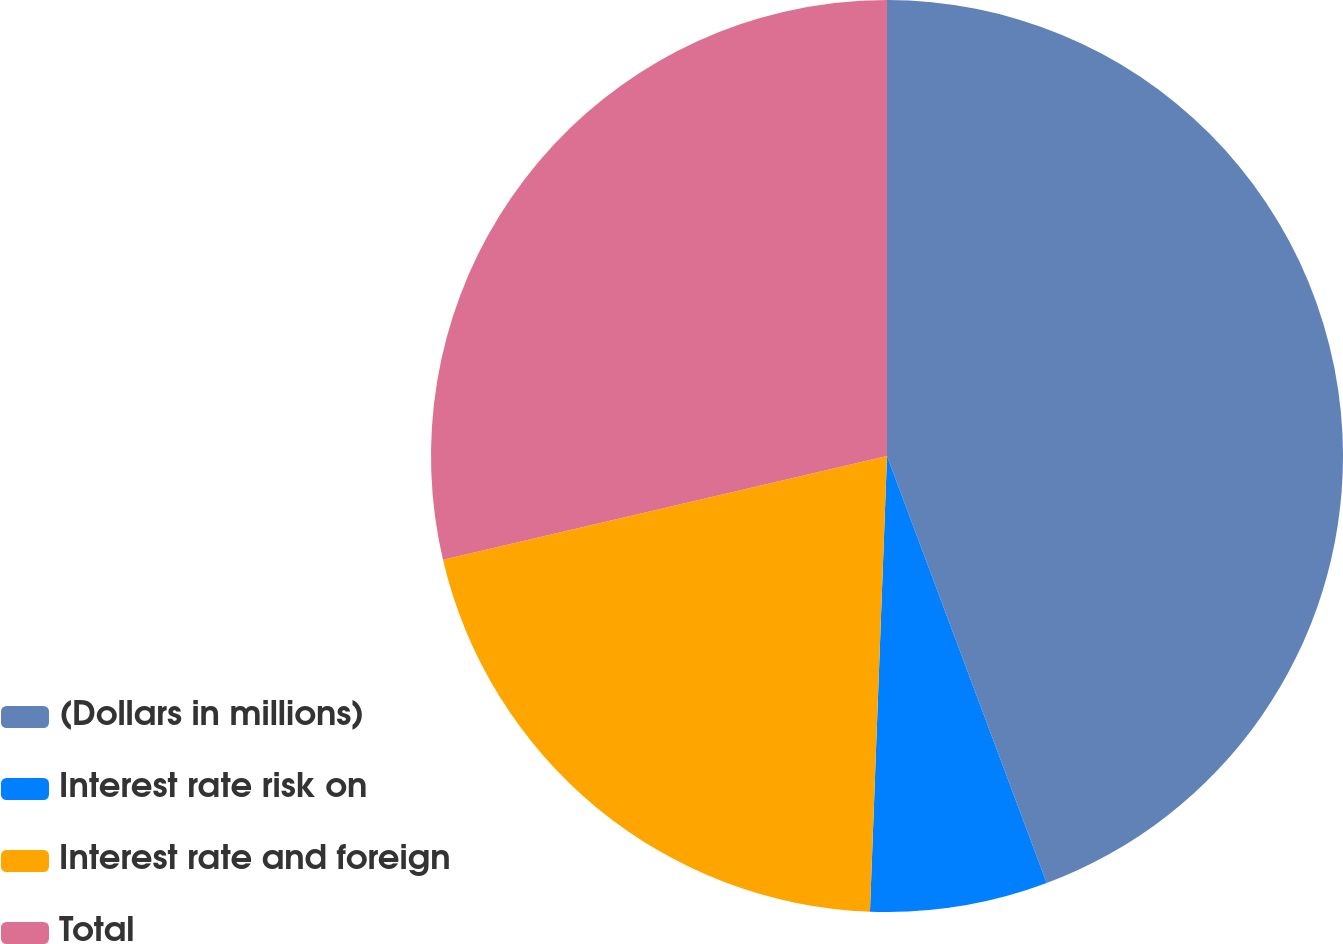Convert chart. <chart><loc_0><loc_0><loc_500><loc_500><pie_chart><fcel>(Dollars in millions)<fcel>Interest rate risk on<fcel>Interest rate and foreign<fcel>Total<nl><fcel>44.31%<fcel>6.29%<fcel>20.75%<fcel>28.66%<nl></chart> 